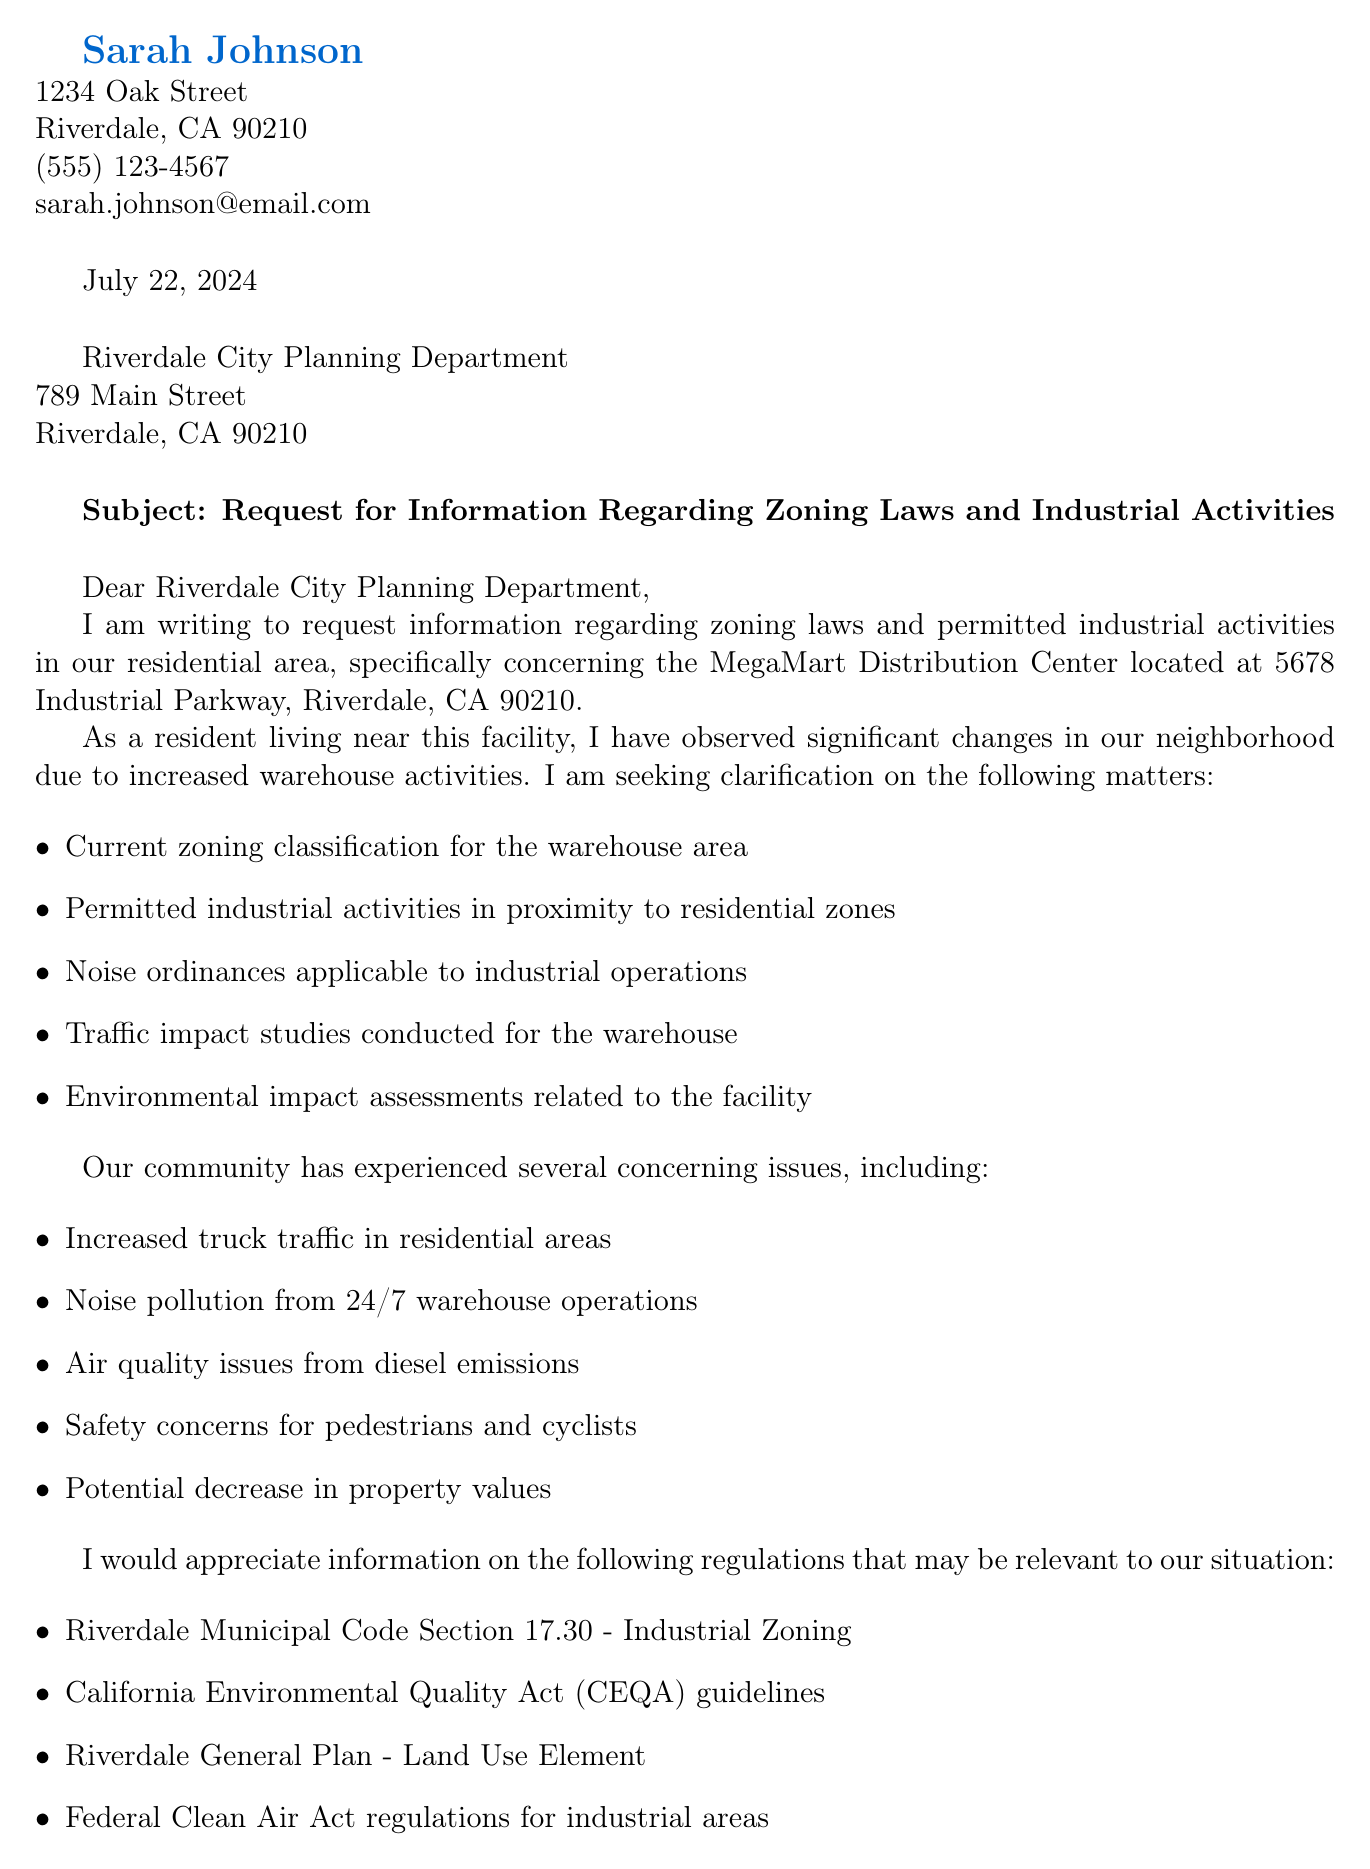What is the name of the sender? The sender identifies herself as Sarah Johnson at the beginning of the document.
Answer: Sarah Johnson What is the address of the MegaMart Distribution Center? The document includes the address of the warehouse located at 5678 Industrial Parkway, Riverdale, CA 90210.
Answer: 5678 Industrial Parkway, Riverdale, CA 90210 What concern is related to safety? The document lists several community concerns, including the specific issue regarding safety for pedestrians and cyclists.
Answer: Safety concerns for pedestrians and cyclists Which zoning classification is requested for review? The letter specifically requests information on the current zoning classification for the warehouse area.
Answer: Current zoning classification for the warehouse area What local organization is mentioned in the letter? The document references local organizations involved in addressing concerns, namely the Riverdale Neighborhood Association.
Answer: Riverdale Neighborhood Association What is the main request addressed to the Riverdale City Planning Department? The letter outlines several requests, with the review of current zoning compliance being highlighted as a key action item.
Answer: Review of current zoning compliance What was one of the environmental regulations mentioned? The letter lists various regulations referring to environmental impacts, among them the California Environmental Quality Act (CEQA) guidelines.
Answer: California Environmental Quality Act (CEQA) guidelines What date is the letter dated? The letter is dated using "\today", which corresponds to the current date when the letter is generated.
Answer: Today's date What is the phone number of the Riverdale City Planning Department? The document provides the contact number for the city planning department, which is (555) 987-6543.
Answer: (555) 987-6543 